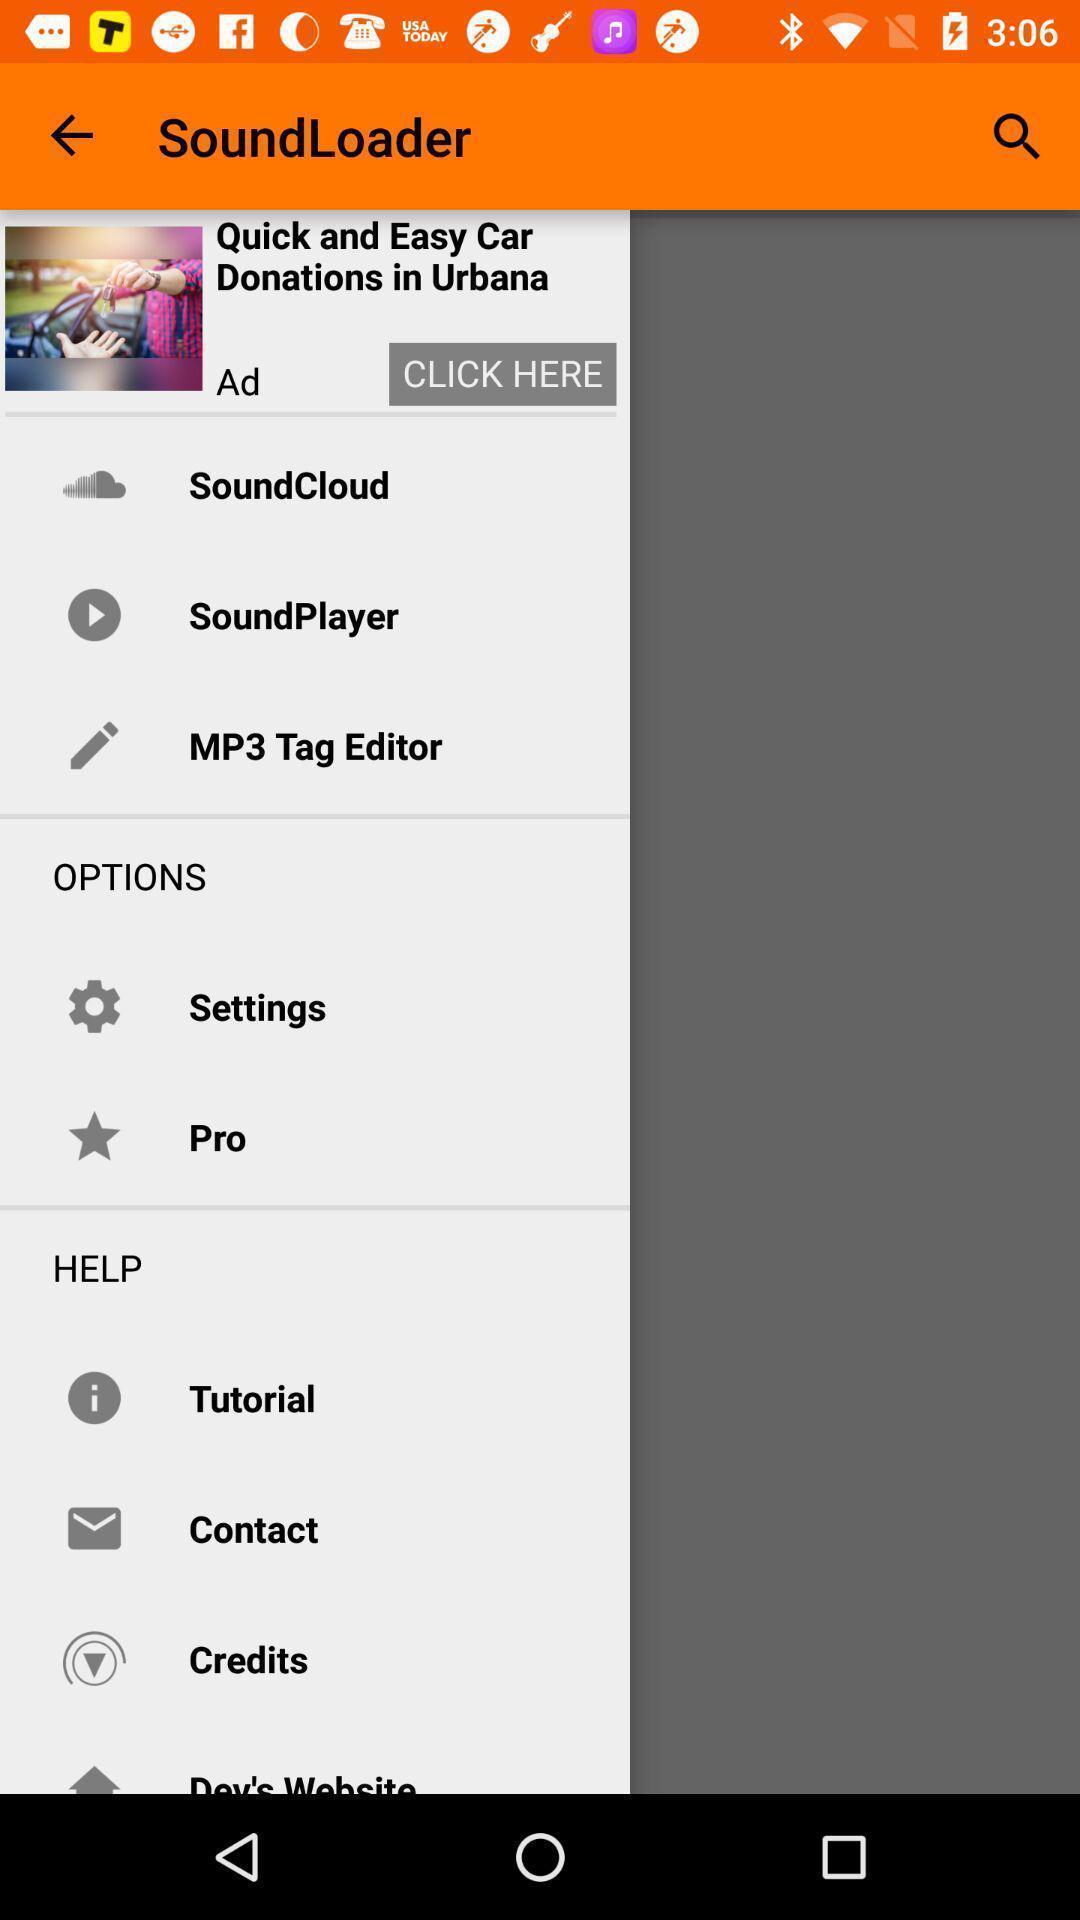Describe this image in words. Pop-up showing list of various options. 